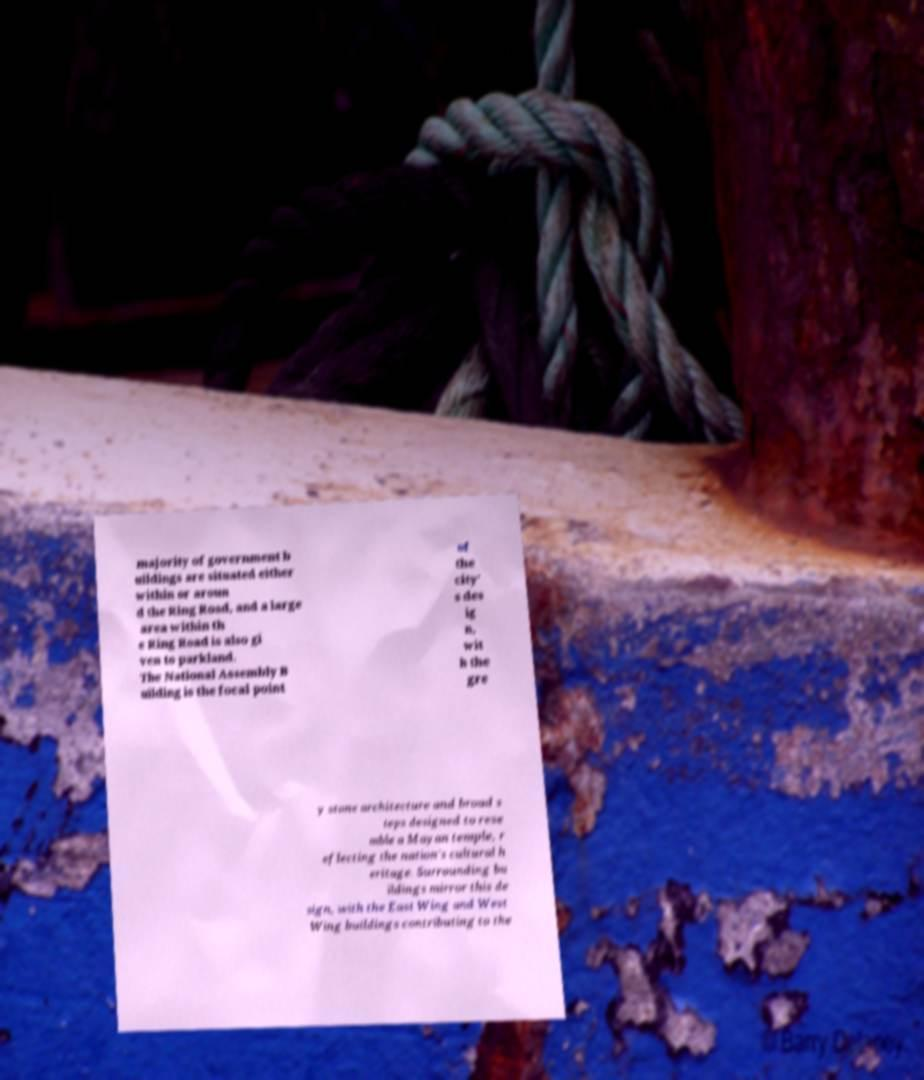Please read and relay the text visible in this image. What does it say? majority of government b uildings are situated either within or aroun d the Ring Road, and a large area within th e Ring Road is also gi ven to parkland. The National Assembly B uilding is the focal point of the city' s des ig n, wit h the gre y stone architecture and broad s teps designed to rese mble a Mayan temple, r eflecting the nation's cultural h eritage. Surrounding bu ildings mirror this de sign, with the East Wing and West Wing buildings contributing to the 